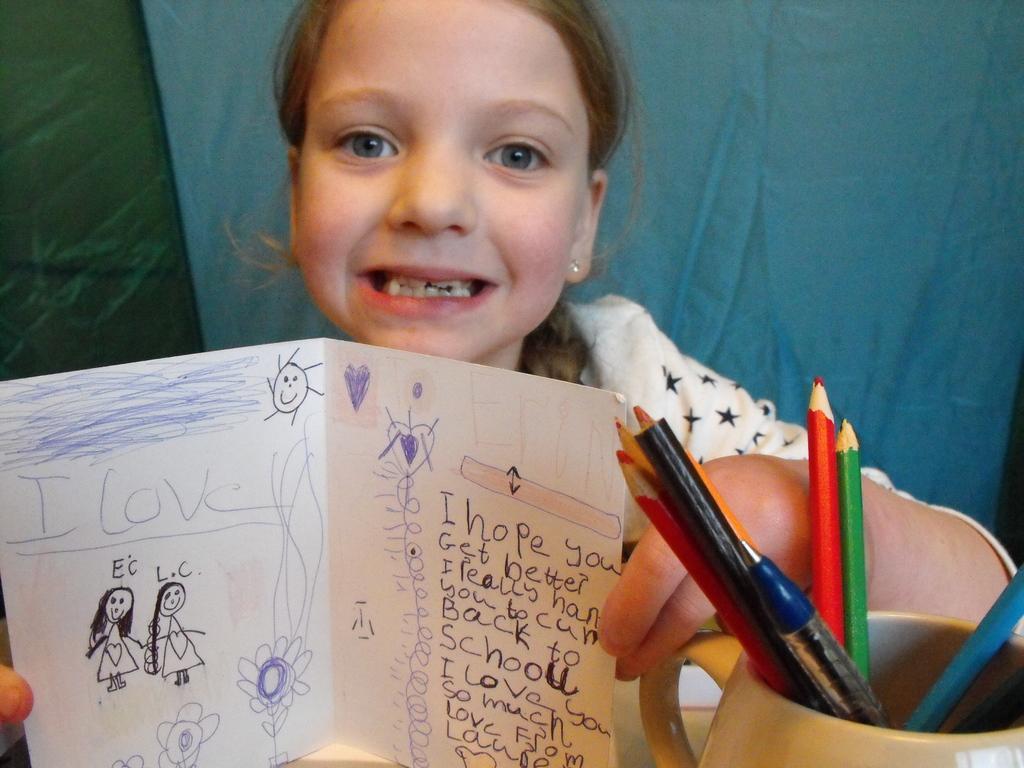Could you give a brief overview of what you see in this image? In this image there is a girl holding a paper, there is text on the paper, there is drawing on the paper, there is a cup towards the bottom of the image, there are objects in the cup, at the background of the image there is a cloth. 